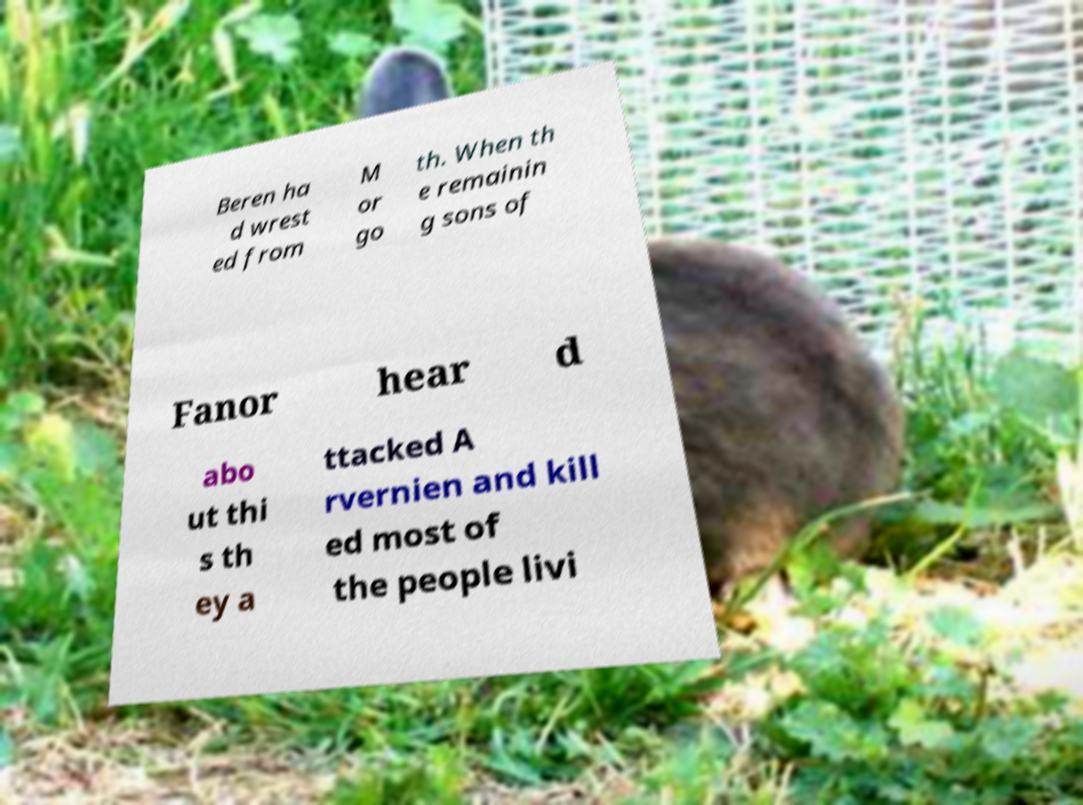There's text embedded in this image that I need extracted. Can you transcribe it verbatim? Beren ha d wrest ed from M or go th. When th e remainin g sons of Fanor hear d abo ut thi s th ey a ttacked A rvernien and kill ed most of the people livi 